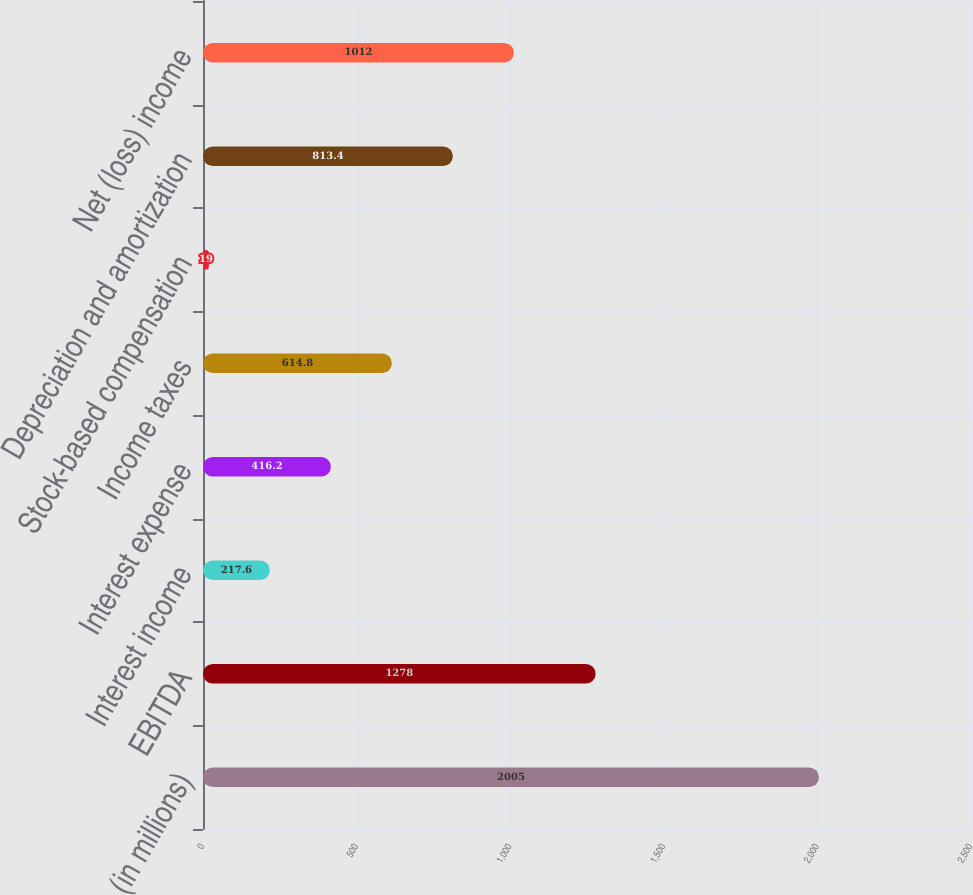<chart> <loc_0><loc_0><loc_500><loc_500><bar_chart><fcel>(in millions)<fcel>EBITDA<fcel>Interest income<fcel>Interest expense<fcel>Income taxes<fcel>Stock-based compensation<fcel>Depreciation and amortization<fcel>Net (loss) income<nl><fcel>2005<fcel>1278<fcel>217.6<fcel>416.2<fcel>614.8<fcel>19<fcel>813.4<fcel>1012<nl></chart> 